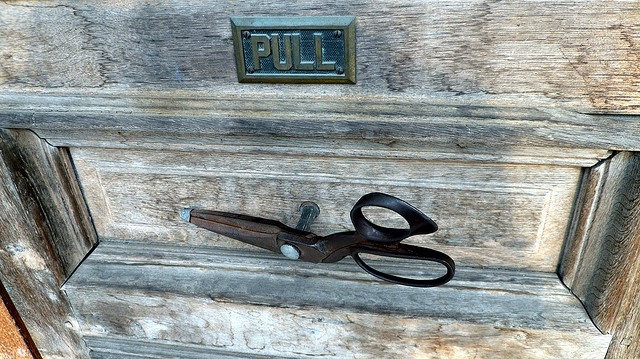Describe the objects in this image and their specific colors. I can see scissors in gray, black, and darkgray tones in this image. 